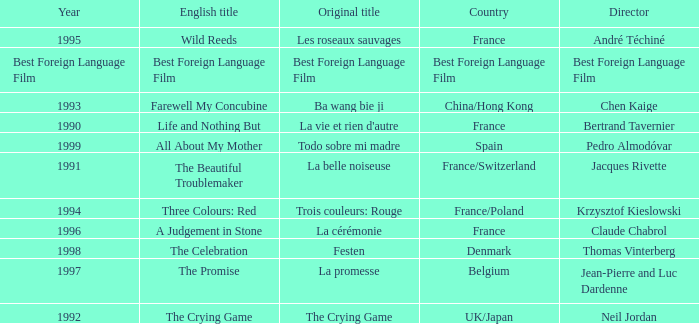Who is the Director of the Original title of The Crying Game? Neil Jordan. 